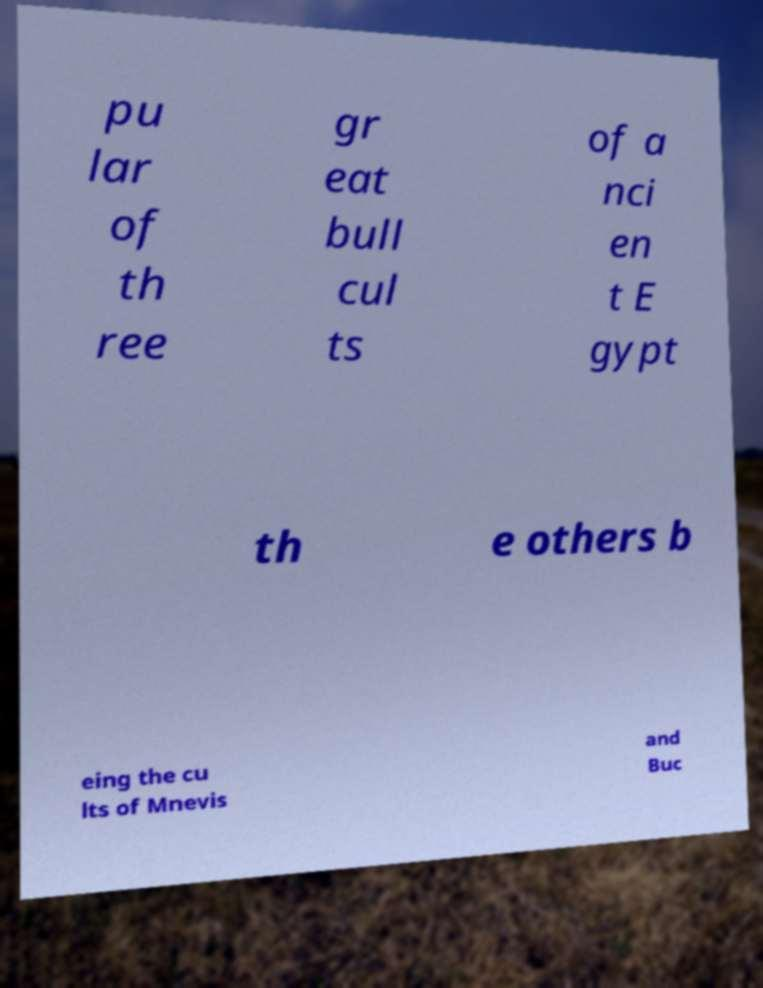Can you accurately transcribe the text from the provided image for me? pu lar of th ree gr eat bull cul ts of a nci en t E gypt th e others b eing the cu lts of Mnevis and Buc 